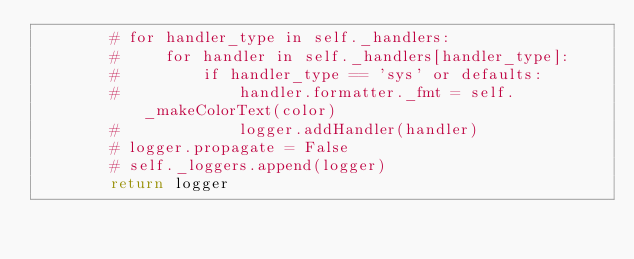<code> <loc_0><loc_0><loc_500><loc_500><_Python_>        # for handler_type in self._handlers:
        #     for handler in self._handlers[handler_type]:
        #         if handler_type == 'sys' or defaults:
        #             handler.formatter._fmt = self._makeColorText(color)
        #             logger.addHandler(handler)
        # logger.propagate = False
        # self._loggers.append(logger)
        return logger
</code> 